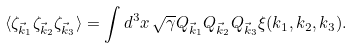<formula> <loc_0><loc_0><loc_500><loc_500>\langle \zeta _ { \vec { k } _ { 1 } } \zeta _ { \vec { k } _ { 2 } } \zeta _ { \vec { k } _ { 3 } } \rangle = \int d ^ { 3 } x \, \sqrt { \gamma } Q _ { \vec { k } _ { 1 } } Q _ { \vec { k } _ { 2 } } Q _ { \vec { k } _ { 3 } } \xi ( k _ { 1 } , k _ { 2 } , k _ { 3 } ) .</formula> 